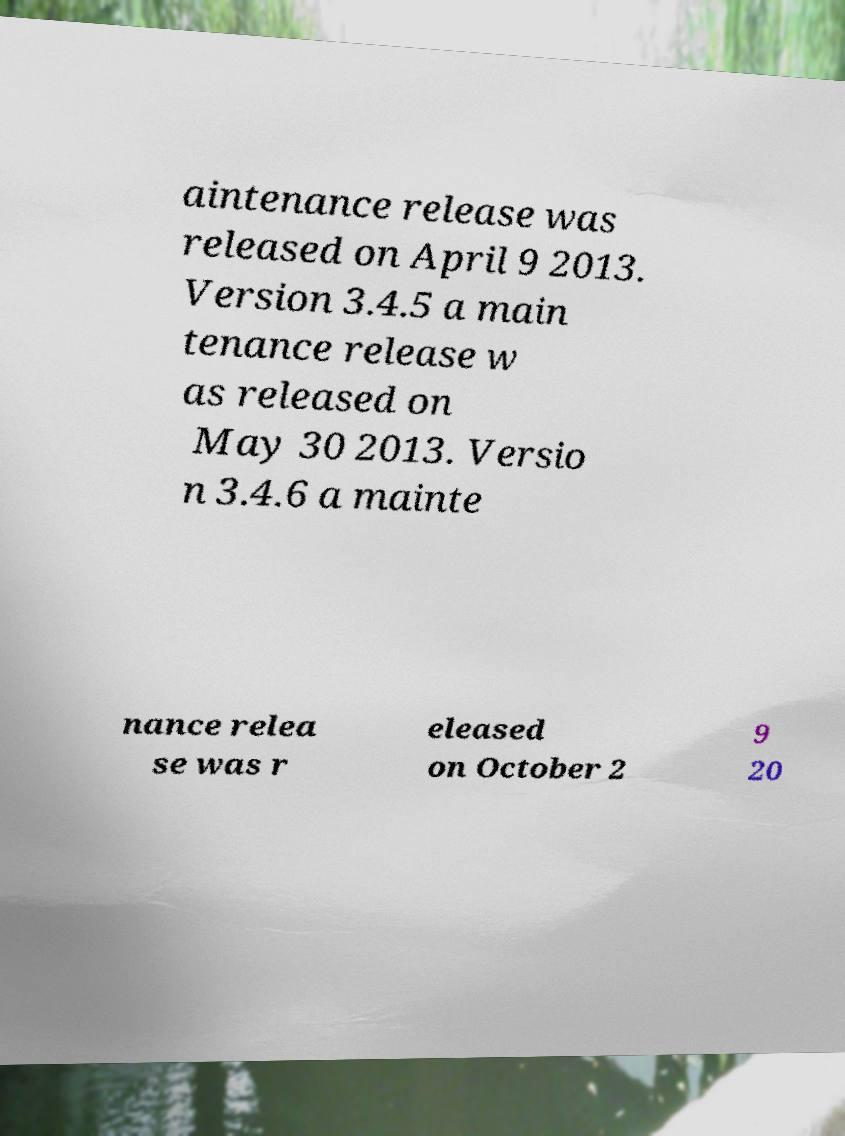I need the written content from this picture converted into text. Can you do that? aintenance release was released on April 9 2013. Version 3.4.5 a main tenance release w as released on May 30 2013. Versio n 3.4.6 a mainte nance relea se was r eleased on October 2 9 20 